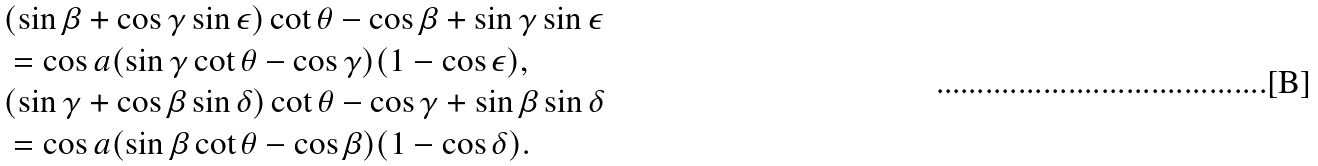Convert formula to latex. <formula><loc_0><loc_0><loc_500><loc_500>& ( \sin \beta + \cos \gamma \sin \epsilon ) \cot \theta - \cos \beta + \sin \gamma \sin \epsilon \\ & = \cos a ( \sin \gamma \cot \theta - \cos \gamma ) ( 1 - \cos \epsilon ) , \\ & ( \sin \gamma + \cos \beta \sin \delta ) \cot \theta - \cos \gamma + \sin \beta \sin \delta \\ & = \cos a ( \sin \beta \cot \theta - \cos \beta ) ( 1 - \cos \delta ) .</formula> 